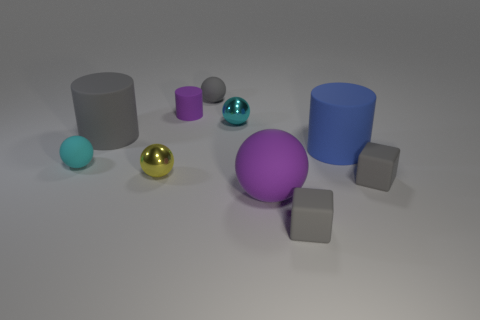Subtract 1 spheres. How many spheres are left? 4 Subtract all gray rubber spheres. How many spheres are left? 4 Subtract all gray spheres. How many spheres are left? 4 Subtract all green spheres. Subtract all gray cubes. How many spheres are left? 5 Subtract all cylinders. How many objects are left? 7 Subtract 0 green cubes. How many objects are left? 10 Subtract all small rubber cylinders. Subtract all large cylinders. How many objects are left? 7 Add 2 big things. How many big things are left? 5 Add 7 green metal objects. How many green metal objects exist? 7 